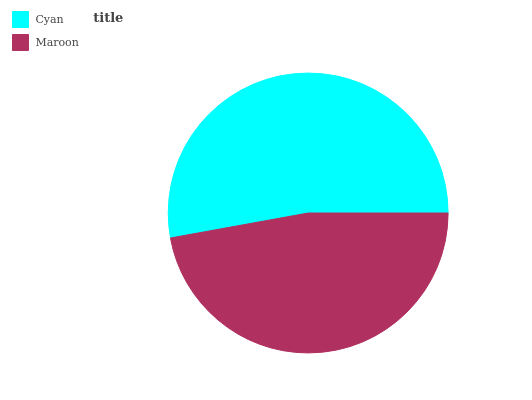Is Maroon the minimum?
Answer yes or no. Yes. Is Cyan the maximum?
Answer yes or no. Yes. Is Maroon the maximum?
Answer yes or no. No. Is Cyan greater than Maroon?
Answer yes or no. Yes. Is Maroon less than Cyan?
Answer yes or no. Yes. Is Maroon greater than Cyan?
Answer yes or no. No. Is Cyan less than Maroon?
Answer yes or no. No. Is Cyan the high median?
Answer yes or no. Yes. Is Maroon the low median?
Answer yes or no. Yes. Is Maroon the high median?
Answer yes or no. No. Is Cyan the low median?
Answer yes or no. No. 